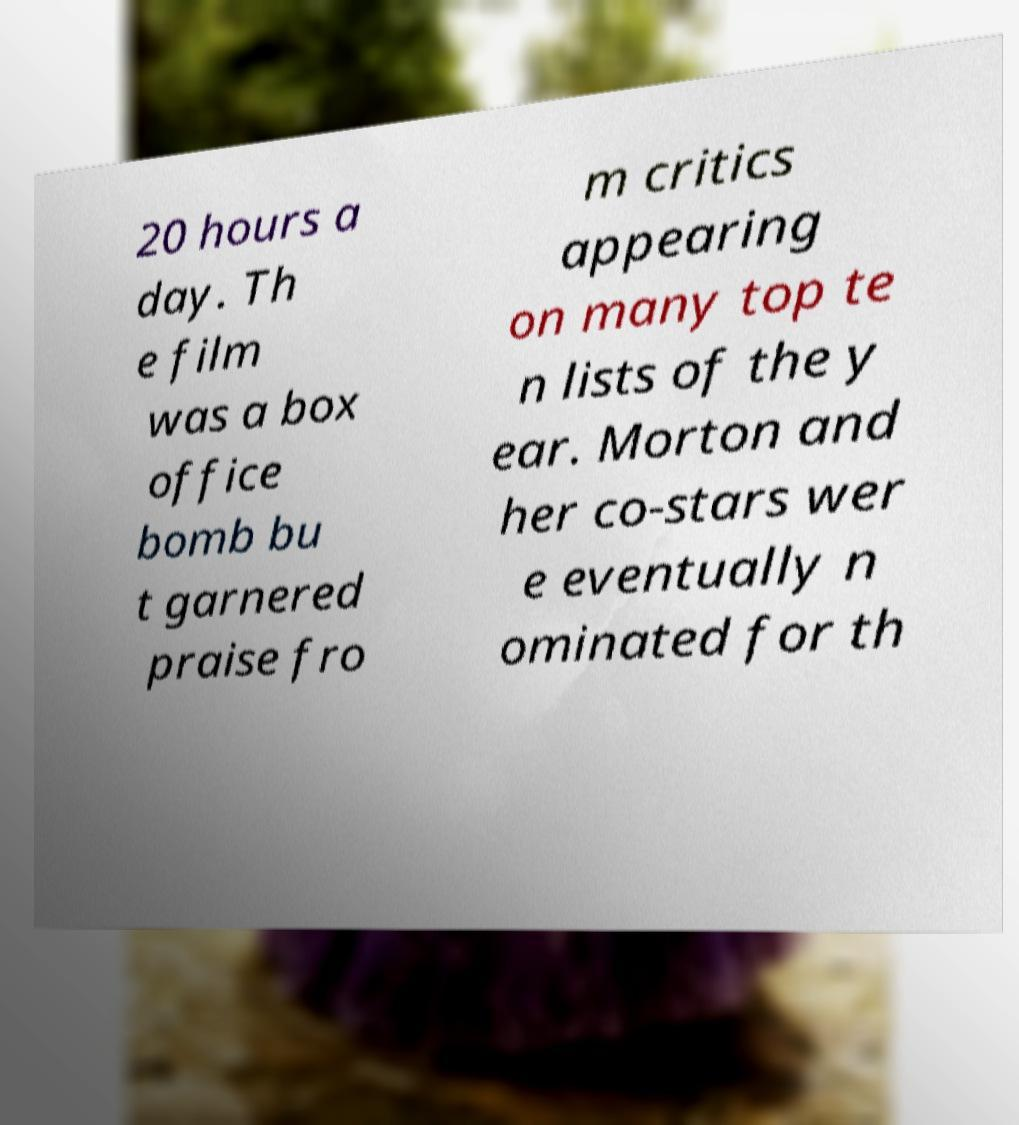There's text embedded in this image that I need extracted. Can you transcribe it verbatim? 20 hours a day. Th e film was a box office bomb bu t garnered praise fro m critics appearing on many top te n lists of the y ear. Morton and her co-stars wer e eventually n ominated for th 